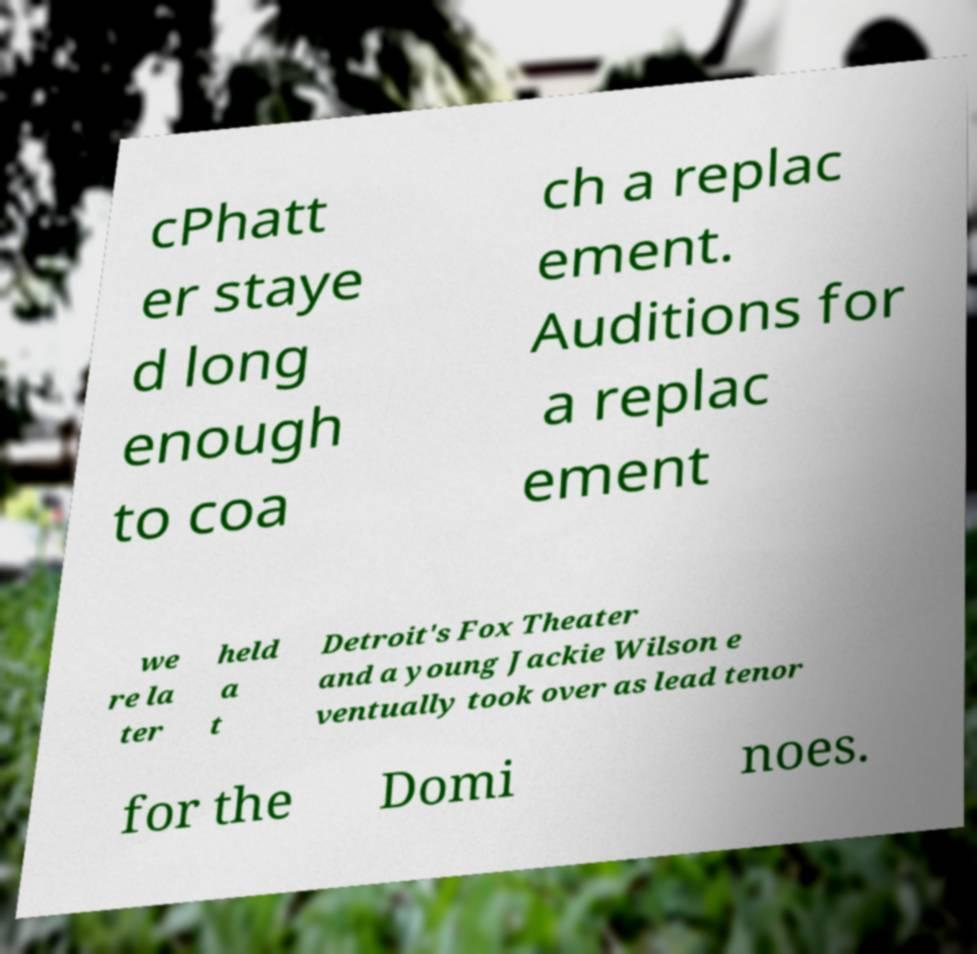Please read and relay the text visible in this image. What does it say? cPhatt er staye d long enough to coa ch a replac ement. Auditions for a replac ement we re la ter held a t Detroit's Fox Theater and a young Jackie Wilson e ventually took over as lead tenor for the Domi noes. 